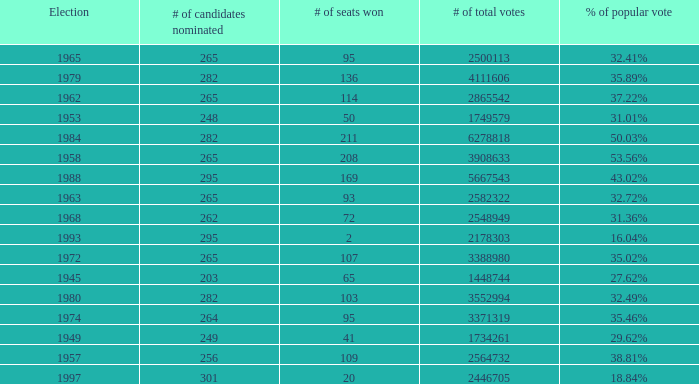What was the lowest # of total votes? 1448744.0. 